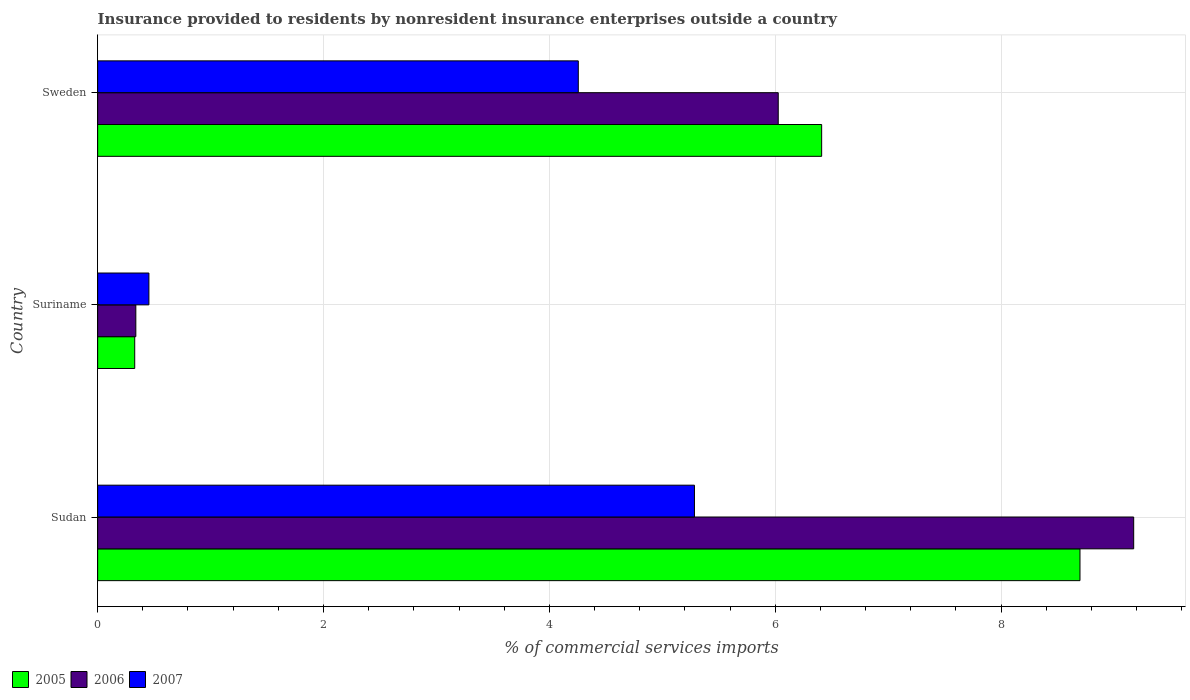How many different coloured bars are there?
Offer a terse response. 3. How many groups of bars are there?
Give a very brief answer. 3. Are the number of bars on each tick of the Y-axis equal?
Offer a very short reply. Yes. How many bars are there on the 2nd tick from the bottom?
Your response must be concise. 3. What is the label of the 3rd group of bars from the top?
Provide a short and direct response. Sudan. What is the Insurance provided to residents in 2005 in Sudan?
Make the answer very short. 8.7. Across all countries, what is the maximum Insurance provided to residents in 2006?
Ensure brevity in your answer.  9.17. Across all countries, what is the minimum Insurance provided to residents in 2007?
Provide a short and direct response. 0.45. In which country was the Insurance provided to residents in 2005 maximum?
Your answer should be compact. Sudan. In which country was the Insurance provided to residents in 2006 minimum?
Ensure brevity in your answer.  Suriname. What is the total Insurance provided to residents in 2007 in the graph?
Give a very brief answer. 10. What is the difference between the Insurance provided to residents in 2005 in Sudan and that in Suriname?
Provide a short and direct response. 8.37. What is the difference between the Insurance provided to residents in 2007 in Sudan and the Insurance provided to residents in 2005 in Suriname?
Your answer should be compact. 4.96. What is the average Insurance provided to residents in 2005 per country?
Your answer should be compact. 5.15. What is the difference between the Insurance provided to residents in 2005 and Insurance provided to residents in 2006 in Suriname?
Keep it short and to the point. -0.01. In how many countries, is the Insurance provided to residents in 2007 greater than 8.8 %?
Keep it short and to the point. 0. What is the ratio of the Insurance provided to residents in 2006 in Sudan to that in Sweden?
Keep it short and to the point. 1.52. Is the difference between the Insurance provided to residents in 2005 in Sudan and Suriname greater than the difference between the Insurance provided to residents in 2006 in Sudan and Suriname?
Ensure brevity in your answer.  No. What is the difference between the highest and the second highest Insurance provided to residents in 2006?
Give a very brief answer. 3.15. What is the difference between the highest and the lowest Insurance provided to residents in 2006?
Your response must be concise. 8.84. In how many countries, is the Insurance provided to residents in 2006 greater than the average Insurance provided to residents in 2006 taken over all countries?
Provide a short and direct response. 2. How many bars are there?
Your answer should be very brief. 9. Are all the bars in the graph horizontal?
Offer a very short reply. Yes. How many countries are there in the graph?
Offer a terse response. 3. Does the graph contain any zero values?
Make the answer very short. No. Does the graph contain grids?
Provide a succinct answer. Yes. How many legend labels are there?
Offer a terse response. 3. How are the legend labels stacked?
Keep it short and to the point. Horizontal. What is the title of the graph?
Give a very brief answer. Insurance provided to residents by nonresident insurance enterprises outside a country. Does "1983" appear as one of the legend labels in the graph?
Provide a succinct answer. No. What is the label or title of the X-axis?
Give a very brief answer. % of commercial services imports. What is the label or title of the Y-axis?
Provide a succinct answer. Country. What is the % of commercial services imports of 2005 in Sudan?
Keep it short and to the point. 8.7. What is the % of commercial services imports in 2006 in Sudan?
Your answer should be compact. 9.17. What is the % of commercial services imports of 2007 in Sudan?
Offer a terse response. 5.29. What is the % of commercial services imports of 2005 in Suriname?
Keep it short and to the point. 0.33. What is the % of commercial services imports of 2006 in Suriname?
Your response must be concise. 0.34. What is the % of commercial services imports of 2007 in Suriname?
Provide a short and direct response. 0.45. What is the % of commercial services imports in 2005 in Sweden?
Provide a short and direct response. 6.41. What is the % of commercial services imports of 2006 in Sweden?
Offer a very short reply. 6.03. What is the % of commercial services imports of 2007 in Sweden?
Your answer should be very brief. 4.26. Across all countries, what is the maximum % of commercial services imports in 2005?
Your response must be concise. 8.7. Across all countries, what is the maximum % of commercial services imports in 2006?
Provide a succinct answer. 9.17. Across all countries, what is the maximum % of commercial services imports in 2007?
Offer a terse response. 5.29. Across all countries, what is the minimum % of commercial services imports in 2005?
Your response must be concise. 0.33. Across all countries, what is the minimum % of commercial services imports in 2006?
Your response must be concise. 0.34. Across all countries, what is the minimum % of commercial services imports of 2007?
Keep it short and to the point. 0.45. What is the total % of commercial services imports in 2005 in the graph?
Keep it short and to the point. 15.44. What is the total % of commercial services imports of 2006 in the graph?
Ensure brevity in your answer.  15.54. What is the total % of commercial services imports of 2007 in the graph?
Offer a very short reply. 10. What is the difference between the % of commercial services imports in 2005 in Sudan and that in Suriname?
Your response must be concise. 8.37. What is the difference between the % of commercial services imports in 2006 in Sudan and that in Suriname?
Offer a terse response. 8.84. What is the difference between the % of commercial services imports in 2007 in Sudan and that in Suriname?
Give a very brief answer. 4.83. What is the difference between the % of commercial services imports of 2005 in Sudan and that in Sweden?
Your response must be concise. 2.29. What is the difference between the % of commercial services imports of 2006 in Sudan and that in Sweden?
Offer a very short reply. 3.15. What is the difference between the % of commercial services imports of 2007 in Sudan and that in Sweden?
Keep it short and to the point. 1.03. What is the difference between the % of commercial services imports in 2005 in Suriname and that in Sweden?
Make the answer very short. -6.08. What is the difference between the % of commercial services imports of 2006 in Suriname and that in Sweden?
Provide a short and direct response. -5.69. What is the difference between the % of commercial services imports of 2007 in Suriname and that in Sweden?
Your answer should be compact. -3.8. What is the difference between the % of commercial services imports in 2005 in Sudan and the % of commercial services imports in 2006 in Suriname?
Offer a very short reply. 8.36. What is the difference between the % of commercial services imports in 2005 in Sudan and the % of commercial services imports in 2007 in Suriname?
Keep it short and to the point. 8.25. What is the difference between the % of commercial services imports in 2006 in Sudan and the % of commercial services imports in 2007 in Suriname?
Your answer should be compact. 8.72. What is the difference between the % of commercial services imports of 2005 in Sudan and the % of commercial services imports of 2006 in Sweden?
Offer a very short reply. 2.67. What is the difference between the % of commercial services imports in 2005 in Sudan and the % of commercial services imports in 2007 in Sweden?
Provide a succinct answer. 4.44. What is the difference between the % of commercial services imports in 2006 in Sudan and the % of commercial services imports in 2007 in Sweden?
Your answer should be compact. 4.92. What is the difference between the % of commercial services imports of 2005 in Suriname and the % of commercial services imports of 2006 in Sweden?
Provide a short and direct response. -5.7. What is the difference between the % of commercial services imports of 2005 in Suriname and the % of commercial services imports of 2007 in Sweden?
Provide a succinct answer. -3.93. What is the difference between the % of commercial services imports of 2006 in Suriname and the % of commercial services imports of 2007 in Sweden?
Offer a very short reply. -3.92. What is the average % of commercial services imports in 2005 per country?
Offer a very short reply. 5.15. What is the average % of commercial services imports of 2006 per country?
Ensure brevity in your answer.  5.18. What is the average % of commercial services imports of 2007 per country?
Your response must be concise. 3.33. What is the difference between the % of commercial services imports of 2005 and % of commercial services imports of 2006 in Sudan?
Your response must be concise. -0.48. What is the difference between the % of commercial services imports in 2005 and % of commercial services imports in 2007 in Sudan?
Your answer should be compact. 3.41. What is the difference between the % of commercial services imports of 2006 and % of commercial services imports of 2007 in Sudan?
Offer a terse response. 3.89. What is the difference between the % of commercial services imports in 2005 and % of commercial services imports in 2006 in Suriname?
Offer a very short reply. -0.01. What is the difference between the % of commercial services imports of 2005 and % of commercial services imports of 2007 in Suriname?
Your answer should be compact. -0.13. What is the difference between the % of commercial services imports of 2006 and % of commercial services imports of 2007 in Suriname?
Your answer should be compact. -0.12. What is the difference between the % of commercial services imports in 2005 and % of commercial services imports in 2006 in Sweden?
Provide a succinct answer. 0.38. What is the difference between the % of commercial services imports of 2005 and % of commercial services imports of 2007 in Sweden?
Your answer should be compact. 2.16. What is the difference between the % of commercial services imports in 2006 and % of commercial services imports in 2007 in Sweden?
Offer a very short reply. 1.77. What is the ratio of the % of commercial services imports of 2005 in Sudan to that in Suriname?
Keep it short and to the point. 26.5. What is the ratio of the % of commercial services imports in 2006 in Sudan to that in Suriname?
Make the answer very short. 27.13. What is the ratio of the % of commercial services imports of 2007 in Sudan to that in Suriname?
Your answer should be very brief. 11.65. What is the ratio of the % of commercial services imports in 2005 in Sudan to that in Sweden?
Give a very brief answer. 1.36. What is the ratio of the % of commercial services imports in 2006 in Sudan to that in Sweden?
Provide a short and direct response. 1.52. What is the ratio of the % of commercial services imports of 2007 in Sudan to that in Sweden?
Your answer should be very brief. 1.24. What is the ratio of the % of commercial services imports in 2005 in Suriname to that in Sweden?
Ensure brevity in your answer.  0.05. What is the ratio of the % of commercial services imports in 2006 in Suriname to that in Sweden?
Provide a short and direct response. 0.06. What is the ratio of the % of commercial services imports of 2007 in Suriname to that in Sweden?
Keep it short and to the point. 0.11. What is the difference between the highest and the second highest % of commercial services imports of 2005?
Ensure brevity in your answer.  2.29. What is the difference between the highest and the second highest % of commercial services imports in 2006?
Your answer should be very brief. 3.15. What is the difference between the highest and the second highest % of commercial services imports of 2007?
Your response must be concise. 1.03. What is the difference between the highest and the lowest % of commercial services imports in 2005?
Provide a succinct answer. 8.37. What is the difference between the highest and the lowest % of commercial services imports of 2006?
Ensure brevity in your answer.  8.84. What is the difference between the highest and the lowest % of commercial services imports in 2007?
Your response must be concise. 4.83. 